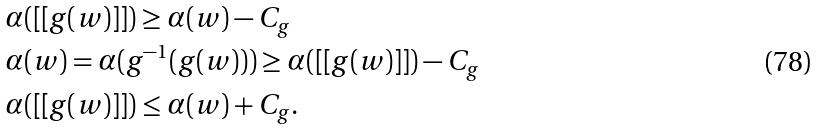Convert formula to latex. <formula><loc_0><loc_0><loc_500><loc_500>& \alpha ( [ [ g ( w ) ] ] ) \geq \alpha ( w ) - C _ { g } \\ & \alpha ( w ) = \alpha ( g ^ { - 1 } ( g ( w ) ) ) \geq \alpha ( [ [ g ( w ) ] ] ) - C _ { g } \\ & \alpha ( [ [ g ( w ) ] ] ) \leq \alpha ( w ) + C _ { g } .</formula> 